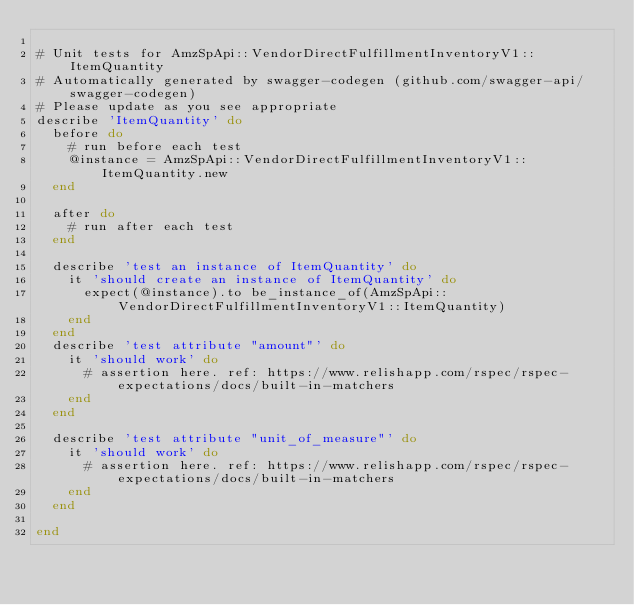Convert code to text. <code><loc_0><loc_0><loc_500><loc_500><_Ruby_>
# Unit tests for AmzSpApi::VendorDirectFulfillmentInventoryV1::ItemQuantity
# Automatically generated by swagger-codegen (github.com/swagger-api/swagger-codegen)
# Please update as you see appropriate
describe 'ItemQuantity' do
  before do
    # run before each test
    @instance = AmzSpApi::VendorDirectFulfillmentInventoryV1::ItemQuantity.new
  end

  after do
    # run after each test
  end

  describe 'test an instance of ItemQuantity' do
    it 'should create an instance of ItemQuantity' do
      expect(@instance).to be_instance_of(AmzSpApi::VendorDirectFulfillmentInventoryV1::ItemQuantity)
    end
  end
  describe 'test attribute "amount"' do
    it 'should work' do
      # assertion here. ref: https://www.relishapp.com/rspec/rspec-expectations/docs/built-in-matchers
    end
  end

  describe 'test attribute "unit_of_measure"' do
    it 'should work' do
      # assertion here. ref: https://www.relishapp.com/rspec/rspec-expectations/docs/built-in-matchers
    end
  end

end
</code> 